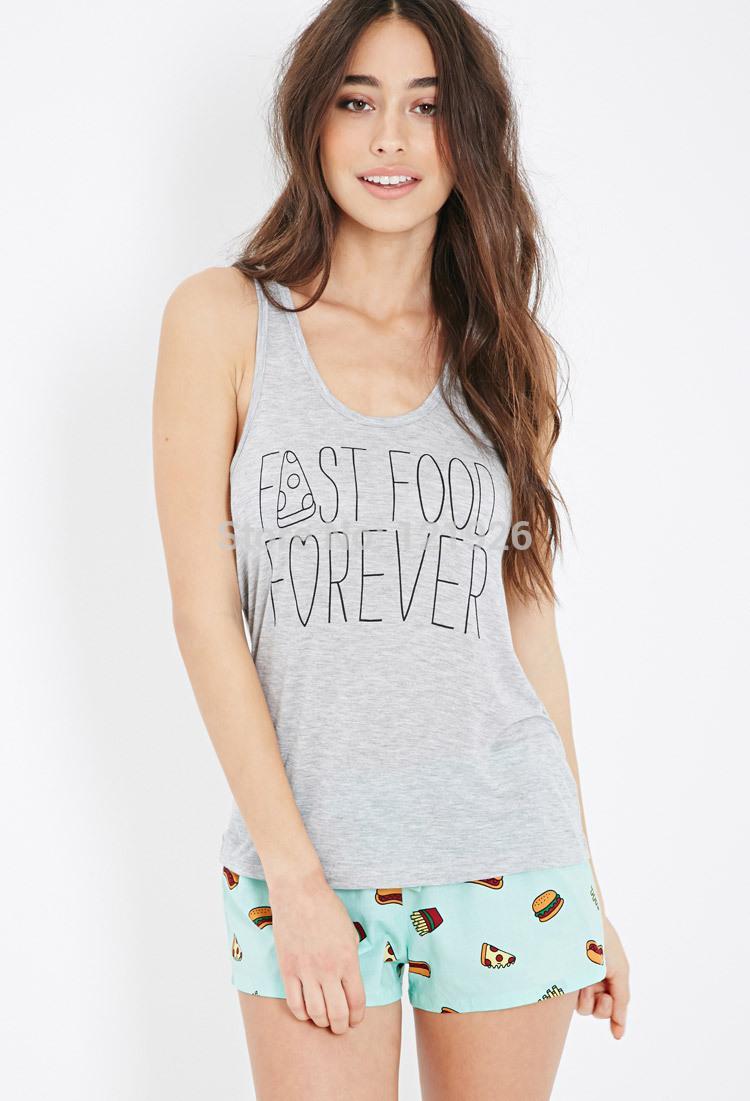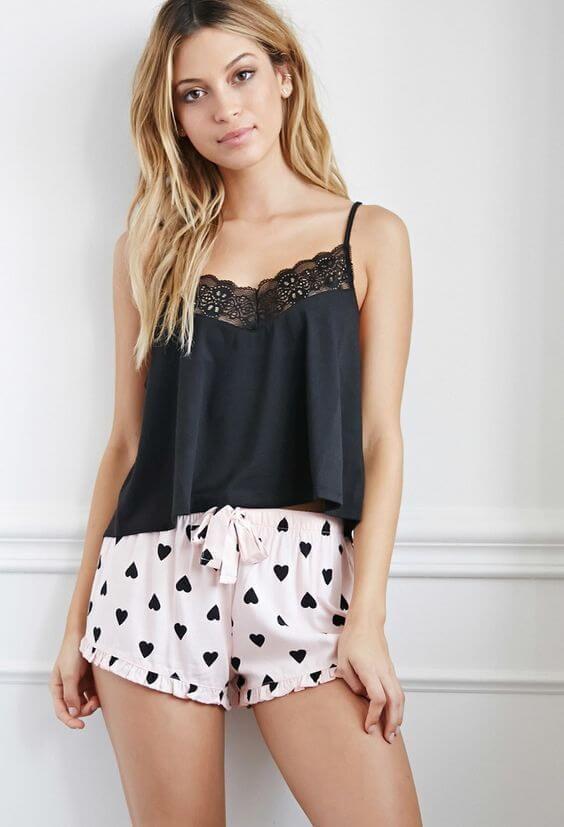The first image is the image on the left, the second image is the image on the right. For the images shown, is this caption "Left and right images feature models wearing same style outfits." true? Answer yes or no. No. The first image is the image on the left, the second image is the image on the right. For the images shown, is this caption "There is a woman wearing a pajama top with no sleeves and a pair of pajama shorts." true? Answer yes or no. Yes. 